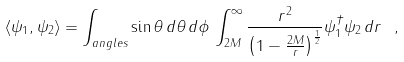<formula> <loc_0><loc_0><loc_500><loc_500>\langle \psi _ { 1 } , \psi _ { 2 } \rangle = \int _ { a n g l e s } \sin \theta \, { d \theta } \, { d \phi } \, \int ^ { \infty } _ { 2 M } \frac { r ^ { 2 } } { \left ( 1 - \frac { 2 M } { r } \right ) ^ { \frac { 1 } { 2 } } } \psi _ { 1 } ^ { \dagger } \psi _ { 2 } \, d r \ ,</formula> 